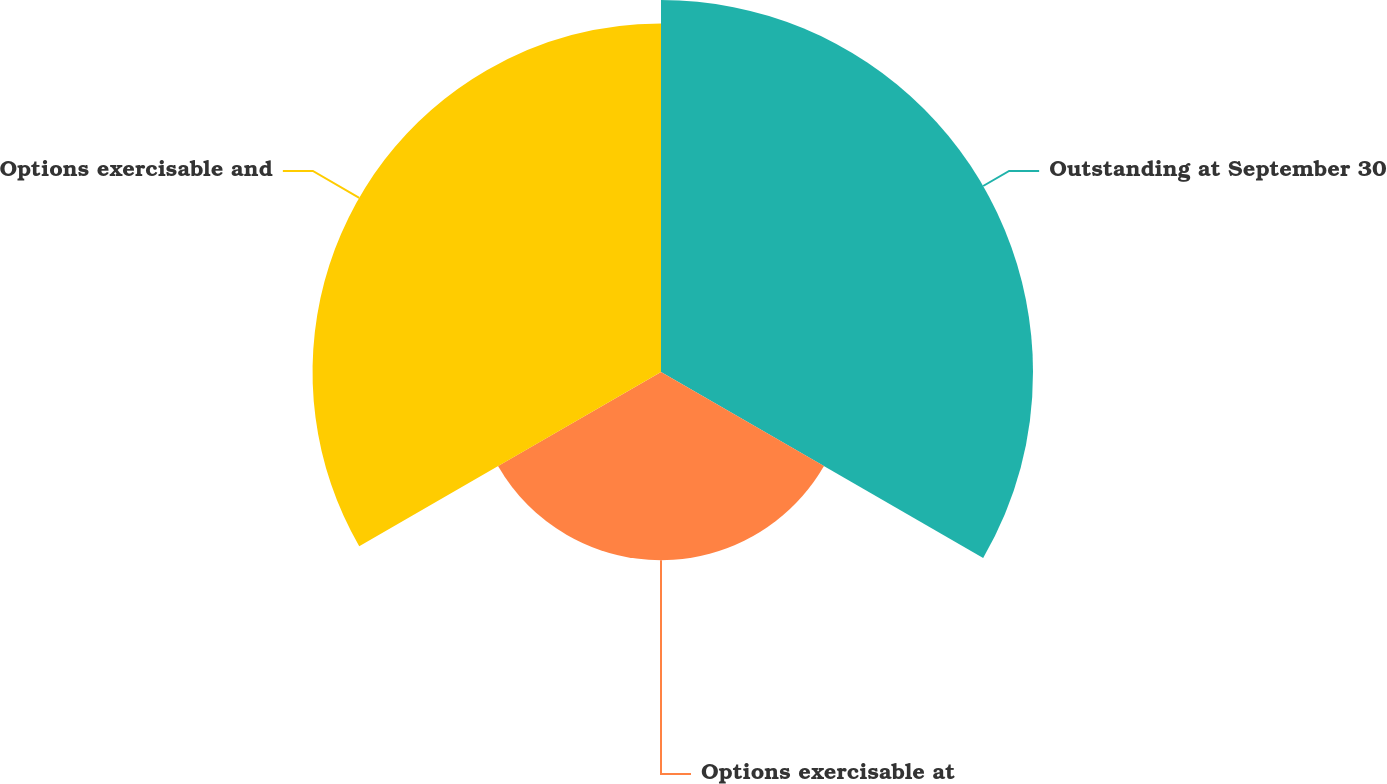<chart> <loc_0><loc_0><loc_500><loc_500><pie_chart><fcel>Outstanding at September 30<fcel>Options exercisable at<fcel>Options exercisable and<nl><fcel>40.94%<fcel>20.71%<fcel>38.35%<nl></chart> 